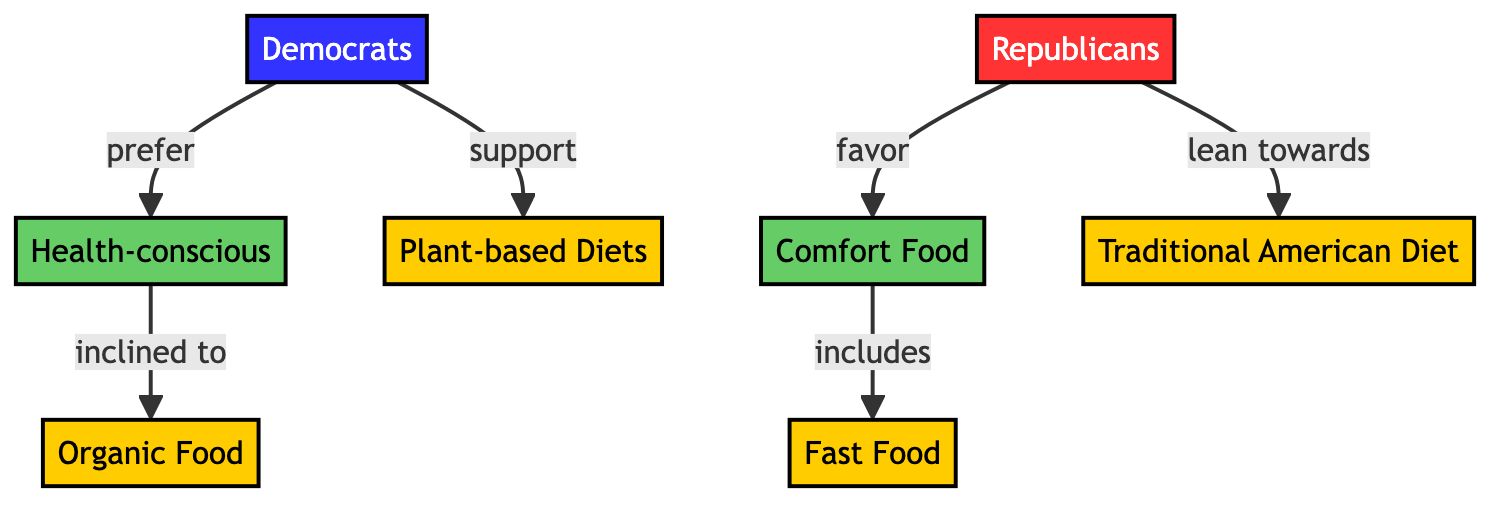What dietary preference do Democrats prefer? According to the diagram, Democrats prefer a Health-conscious diet. The arrow labeled "prefer" indicates the connection from the Democrats node to the Health-conscious node.
Answer: Health-conscious Which diet is favored by Republicans? The diagram shows that Republicans favor Comfort Food. There is an arrow labeled "favor" pointing from the Republicans node to the Comfort Food node.
Answer: Comfort Food What type of diet do Democrats support? The diagram indicates that Democrats support Plant-based Diets. This is represented by the arrow labeled "support" connecting Democrats to the Plant-based Diets node.
Answer: Plant-based Diets What includes Comfort Food? The diagram shows that Fast Food is included under the Comfort Food category, as denoted by the arrow labeled "includes" from Comfort to Fast Food.
Answer: Fast Food How many dietary preferences are indicated in the diagram? There are a total of two dietary preferences: Health-conscious and Comfort Food. These preferences are represented by their respective nodes connected to the political affiliations.
Answer: 2 Which food category do Health-conscious individuals tend to be inclined towards? The diagram outlines that Health-conscious individuals are inclined to choose Organic Food, represented by the arrow labeled "inclined to" pointing from Health to Organic.
Answer: Organic Food Which political affiliation is associated with the Traditional American Diet? According to the diagram, the Traditional American Diet is associated with Republicans, as denoted by the arrow labeled "lean towards" pointing from Republicans to Traditional American Diet.
Answer: Republicans What is the relationship between Republicans and Fast Food? The diagram shows that Republicans do not have a direct relationship with Fast Food; rather, Fast Food is included as part of Comfort Food, which Republicans favor. The flow indicates a multi-step connection: Republicans -> Comfort -> Fast.
Answer: Indirect What type of diet do Health-conscious individuals prefer? The Health-conscious individuals prefer Organic Food as indicated by the connection from Health to Organic with the label "inclined to."
Answer: Organic Food 